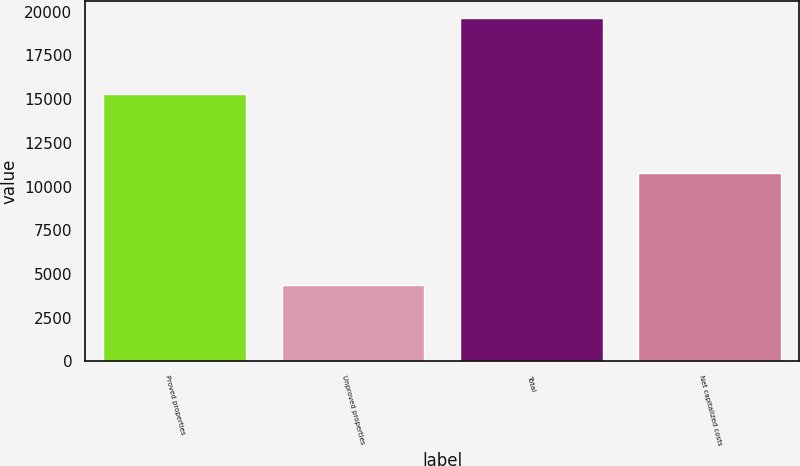Convert chart to OTSL. <chart><loc_0><loc_0><loc_500><loc_500><bar_chart><fcel>Proved properties<fcel>Unproved properties<fcel>Total<fcel>Net capitalized costs<nl><fcel>15288<fcel>4344<fcel>19632<fcel>10774<nl></chart> 